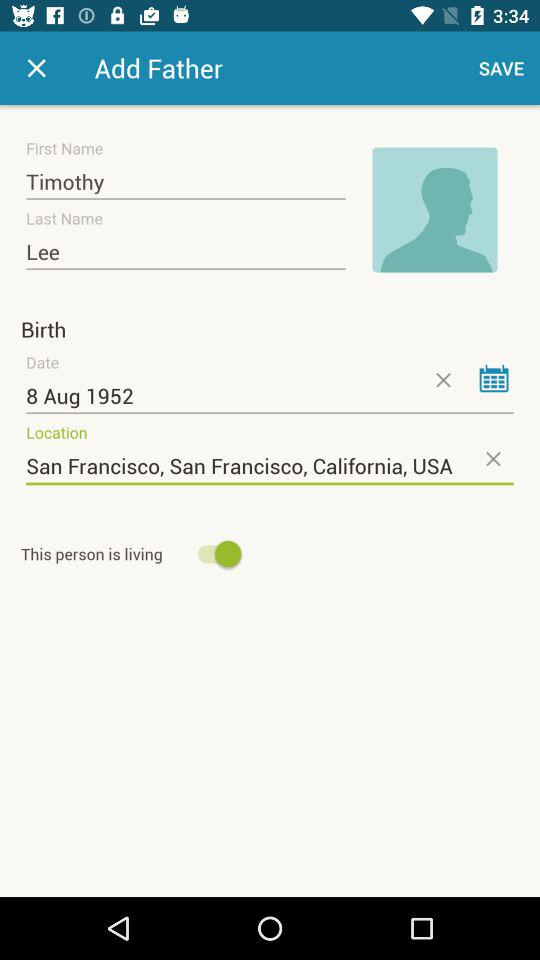What is the location?
Answer the question using a single word or phrase. The location is "San Francisco, California, USA" 